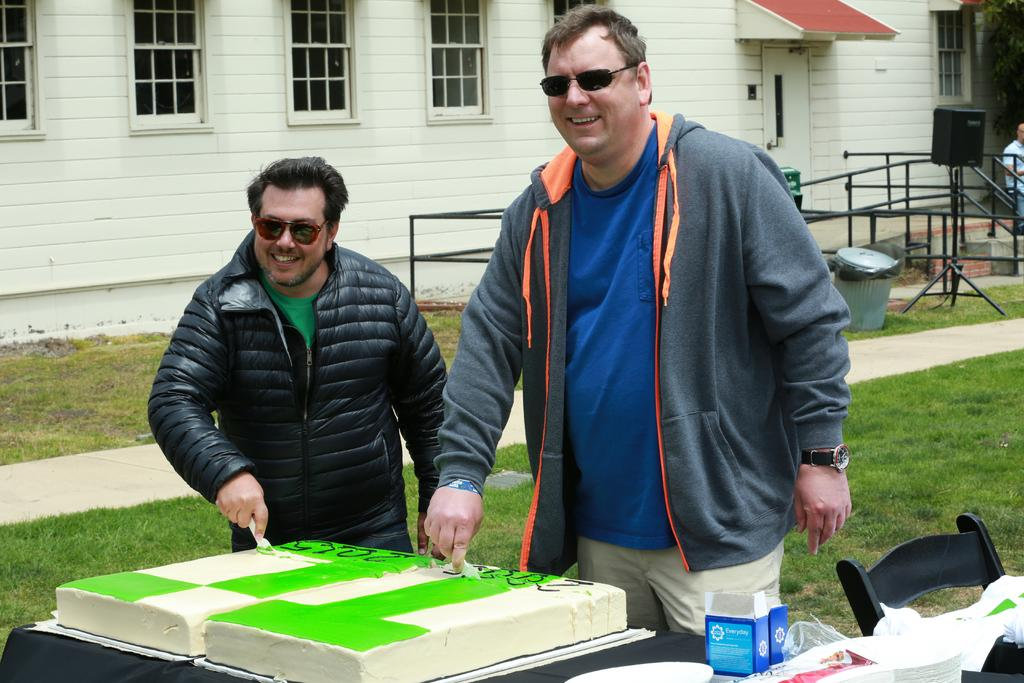How many people are present in the image? There are two people in the image. What are the people wearing? The people are wearing jackets. What activity are the people engaged in? The people are cutting a cake. Where is the cake located in relation to the people? The cake is in front of the people. Can you tell me how many kitties are swimming in the sea in the image? There are no kitties or sea present in the image; it features two people cutting a cake. 